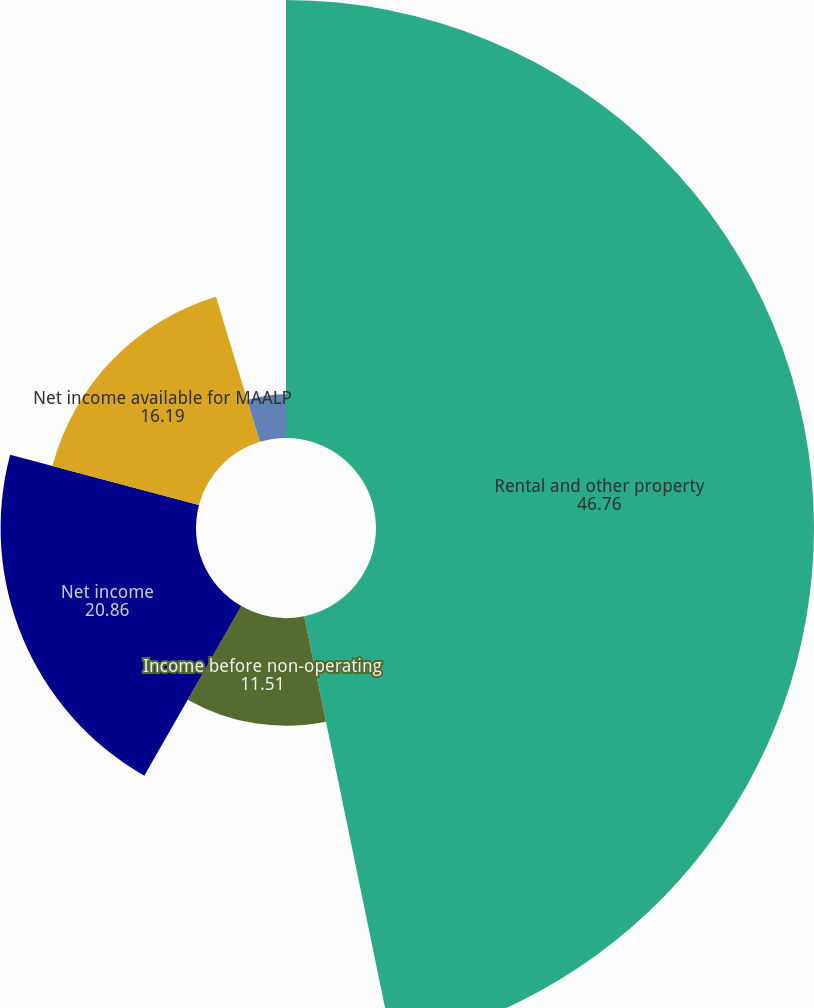Convert chart to OTSL. <chart><loc_0><loc_0><loc_500><loc_500><pie_chart><fcel>Rental and other property<fcel>Income before non-operating<fcel>Net income<fcel>Net income available for MAALP<fcel>Earnings per common unit -<nl><fcel>46.76%<fcel>11.51%<fcel>20.86%<fcel>16.19%<fcel>4.68%<nl></chart> 